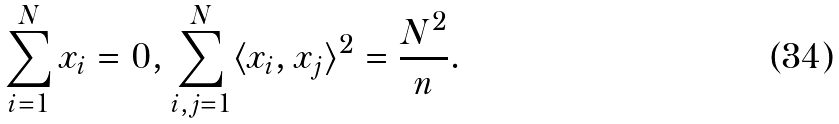Convert formula to latex. <formula><loc_0><loc_0><loc_500><loc_500>\sum _ { i = 1 } ^ { N } x _ { i } = 0 , \sum _ { i , j = 1 } ^ { N } \langle x _ { i } , x _ { j } \rangle ^ { 2 } = \frac { N ^ { 2 } } n .</formula> 